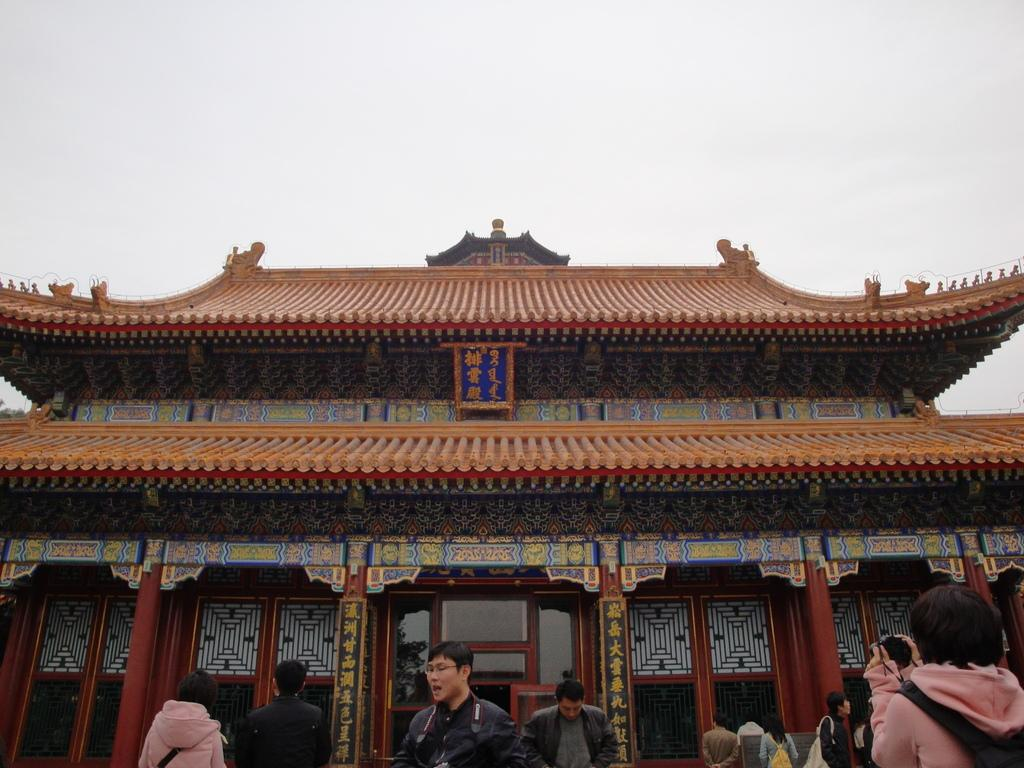How many people are in the image? There is a group of people in the image, but the exact number cannot be determined from the provided facts. What can be seen in the background of the image? There is a building in the background of the image. What is on the building? There is a hoarding on the building. What color are the eyes of the person in the image? There is no information about the color of anyone's eyes in the image. What type of produce is being sold on the hoarding? There is no produce mentioned or depicted on the hoarding in the image. 